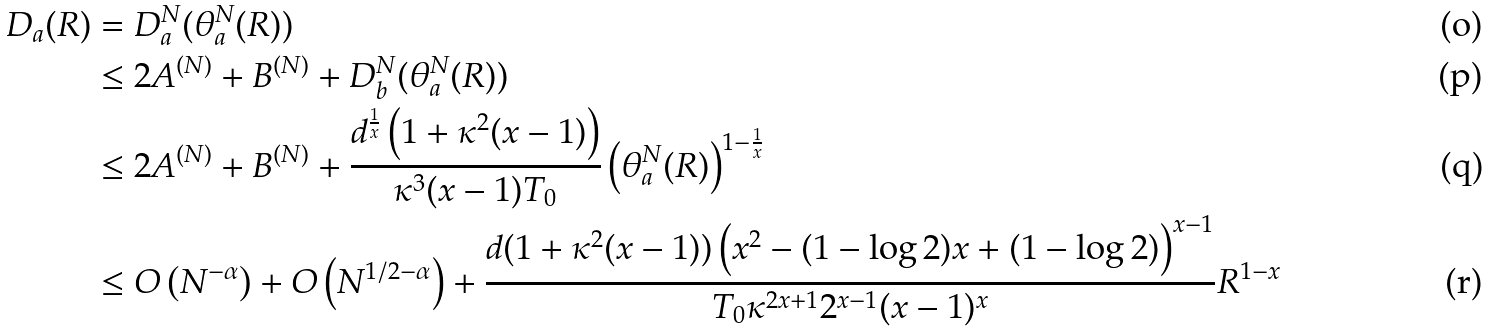Convert formula to latex. <formula><loc_0><loc_0><loc_500><loc_500>D _ { a } ( R ) & = D _ { a } ^ { N } ( \theta _ { a } ^ { N } ( R ) ) \\ & \leq 2 A ^ { ( N ) } + B ^ { ( N ) } + D _ { b } ^ { N } ( \theta _ { a } ^ { N } ( R ) ) \\ & \leq 2 A ^ { ( N ) } + B ^ { ( N ) } + \frac { d ^ { \frac { 1 } { x } } \left ( 1 + \kappa ^ { 2 } ( x - 1 ) \right ) } { \kappa ^ { 3 } ( x - 1 ) T _ { 0 } } \left ( \theta _ { a } ^ { N } ( R ) \right ) ^ { 1 - \frac { 1 } { x } } \\ & \leq O \left ( N ^ { - \alpha } \right ) + O \left ( N ^ { 1 / 2 - \alpha } \right ) + \frac { d ( 1 + \kappa ^ { 2 } ( x - 1 ) ) \left ( x ^ { 2 } - ( 1 - \log 2 ) x + ( 1 - \log 2 ) \right ) ^ { x - 1 } } { T _ { 0 } \kappa ^ { 2 x + 1 } 2 ^ { x - 1 } ( x - 1 ) ^ { x } } R ^ { 1 - x }</formula> 